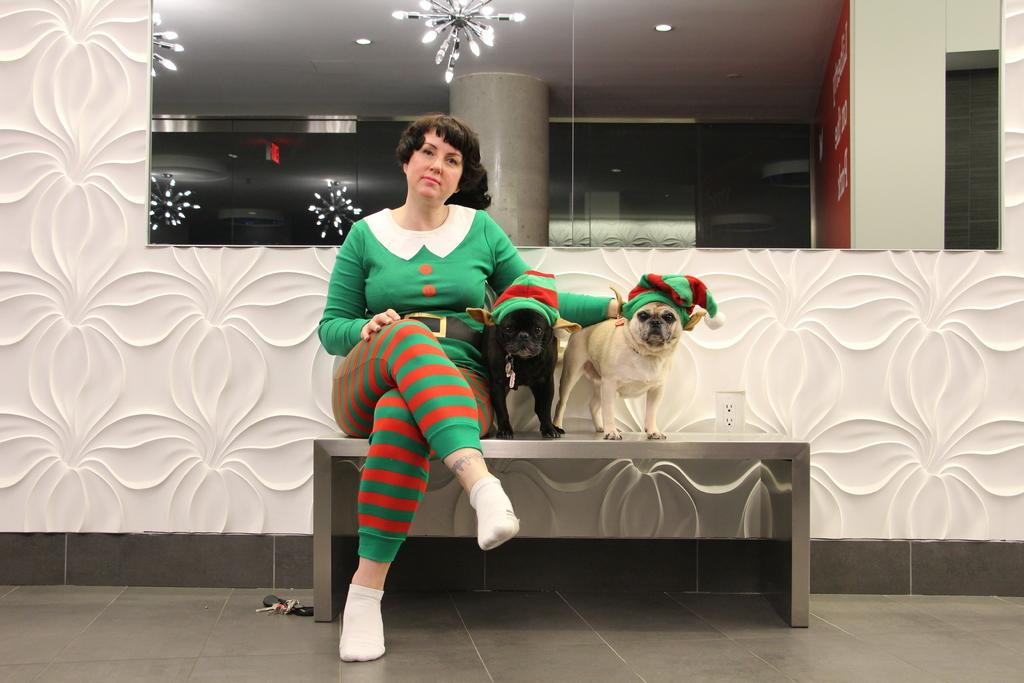Who is present in the image? There is a woman in the image. What animals can be seen in the image? There are two dogs in the image. What object is present that can be used for reflection? There is a mirror in the image. How many ants can be seen crawling on the cracker in the image? There are no ants or crackers present in the image. What type of clothing is the woman wearing to protect herself from the winter cold in the image? The image does not show any indication of winter weather or the woman wearing protective clothing. 